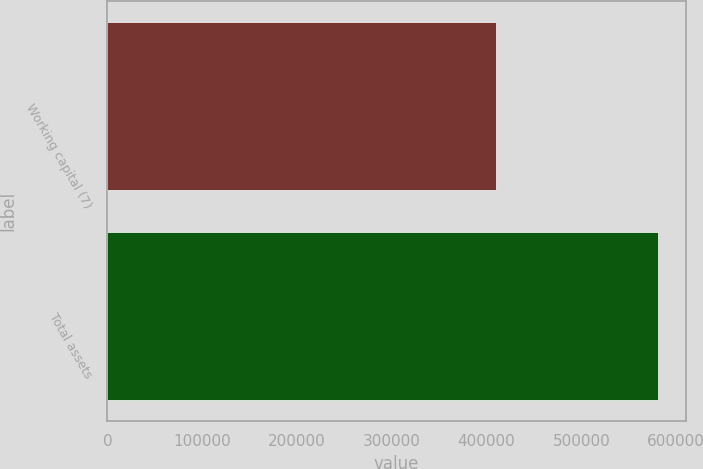Convert chart. <chart><loc_0><loc_0><loc_500><loc_500><bar_chart><fcel>Working capital (7)<fcel>Total assets<nl><fcel>410248<fcel>581232<nl></chart> 